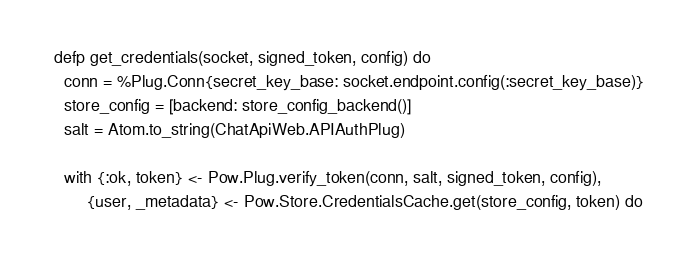<code> <loc_0><loc_0><loc_500><loc_500><_Elixir_>
  defp get_credentials(socket, signed_token, config) do
    conn = %Plug.Conn{secret_key_base: socket.endpoint.config(:secret_key_base)}
    store_config = [backend: store_config_backend()]
    salt = Atom.to_string(ChatApiWeb.APIAuthPlug)

    with {:ok, token} <- Pow.Plug.verify_token(conn, salt, signed_token, config),
         {user, _metadata} <- Pow.Store.CredentialsCache.get(store_config, token) do</code> 